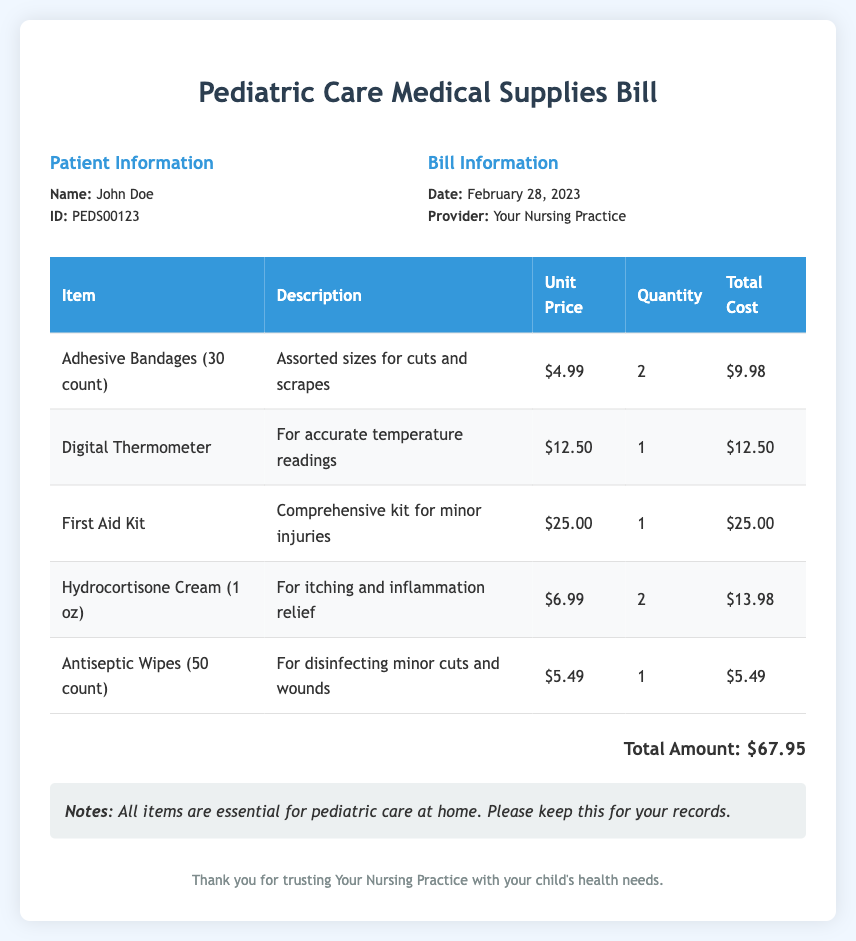What is the total amount of the bill? The total amount is indicated at the bottom of the document as the sum of all item costs.
Answer: $67.95 Who is the patient mentioned in the bill? The patient's name is listed under the Patient Information section.
Answer: John Doe What date was the bill issued? The date is found in the Bill Information section.
Answer: February 28, 2023 How many units of adhesive bandages were purchased? The quantity is specified in the table under the Adhesive Bandages line.
Answer: 2 What item is included for temperature readings? This item is listed under the medical supplies table.
Answer: Digital Thermometer What is the unit price of the First Aid Kit? The unit price is stated in the table corresponding to the First Aid Kit item.
Answer: $25.00 How many antiseptic wipes were purchased? The quantity of antiseptic wipes can be found in the product description in the table.
Answer: 1 What type of cream is included in the purchases? The item is mentioned in the table for its use related to itching and inflammation.
Answer: Hydrocortisone Cream What does the notes section emphasize about the items? The notes highlight the importance of the items in pediatric care at home, as stated in the document.
Answer: Essential for pediatric care at home 